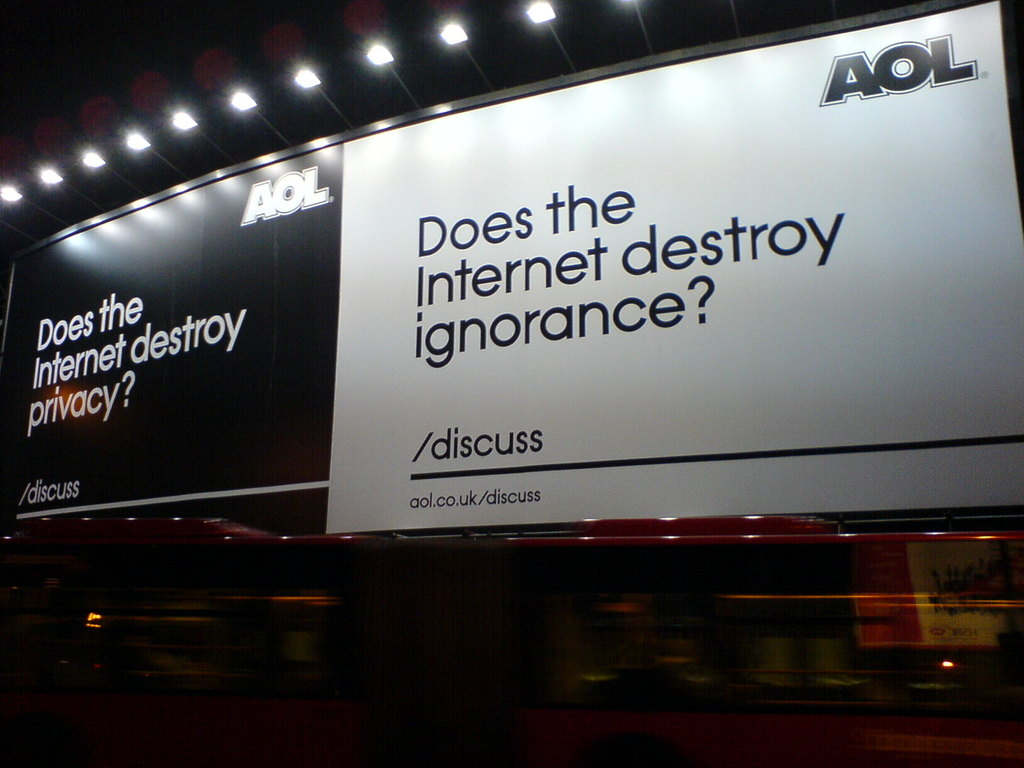Can you elaborate on the elements of the picture provided?
 The image captures a thought-provoking advertisement by AOL, displayed on the side of a bus. The billboard, set against a stark black background, poses two profound questions in white text: "Does the Internet destroy privacy?" and "Does the Internet destroy ignorance?". Each question is followed by the word "discuss", inviting viewers to ponder and engage in a dialogue about these pertinent issues. The AOL logo and a website link, "aol.co.uk/discuss", are also present, indicating that the discussion is likely to take place on this platform. This advertisement cleverly uses the power of questions to stimulate thought and conversation about the impact of the Internet on privacy and knowledge. 